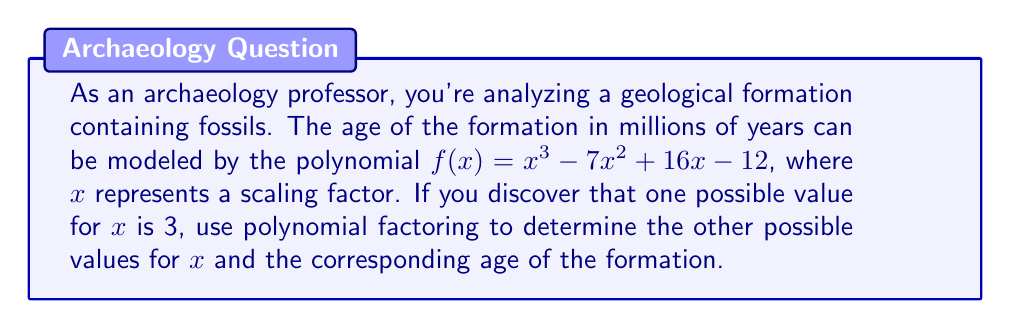Help me with this question. To solve this problem, we'll use polynomial factoring techniques:

1) Given that $x = 3$ is a solution, $(x - 3)$ is a factor of the polynomial.

2) Let's use polynomial long division to find the other factor:

   $$\frac{x^3 - 7x^2 + 16x - 12}{x - 3} = x^2 - 4x + 4$$

3) Therefore, $f(x) = (x - 3)(x^2 - 4x + 4)$

4) We can factor the quadratic term further:
   $x^2 - 4x + 4 = (x - 2)^2$

5) So, the fully factored polynomial is:
   $f(x) = (x - 3)(x - 2)^2$

6) The roots of this polynomial are:
   $x = 3$ (given)
   $x = 2$ (with multiplicity 2)

7) To find the age of the formation, we evaluate $f(x)$ at these values:

   For $x = 3$: $f(3) = 3^3 - 7(3)^2 + 16(3) - 12 = 27 - 63 + 48 - 12 = 0$

   For $x = 2$: $f(2) = 2^3 - 7(2)^2 + 16(2) - 12 = 8 - 28 + 32 - 12 = 0$

8) Since both values of $x$ result in $f(x) = 0$, the age of the formation is 0 million years in both cases. This suggests that the model might need refinement or that the formation is relatively recent in geological terms.
Answer: The possible values for $x$ are 3 and 2 (with multiplicity 2). The corresponding age of the formation is 0 million years for both values of $x$. 